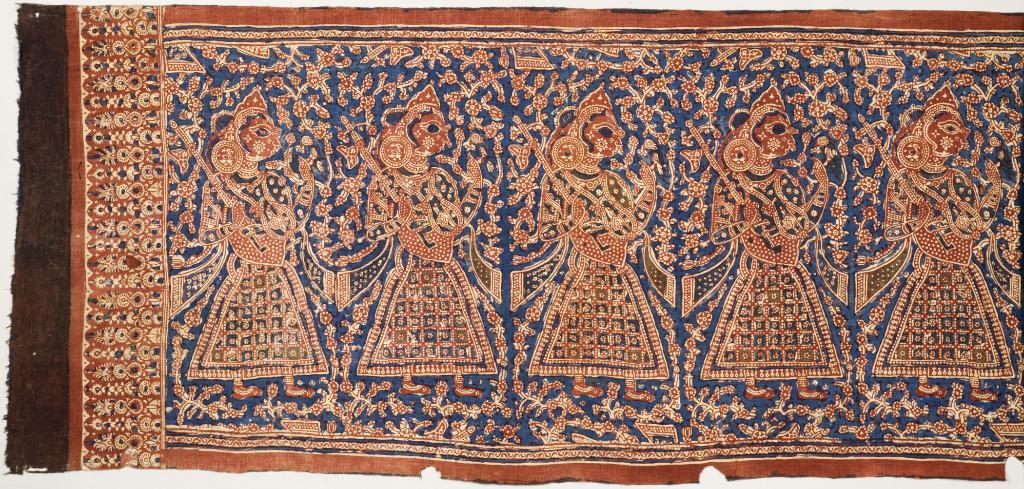What type of flooring is visible in the image? There is a carpet in the image. Can you describe the appearance of the carpet? The carpet has a lot of designs. What is the opinion of the man in the image about the carpet's design? There is no man present in the image, so it is not possible to determine his opinion about the carpet's design. 